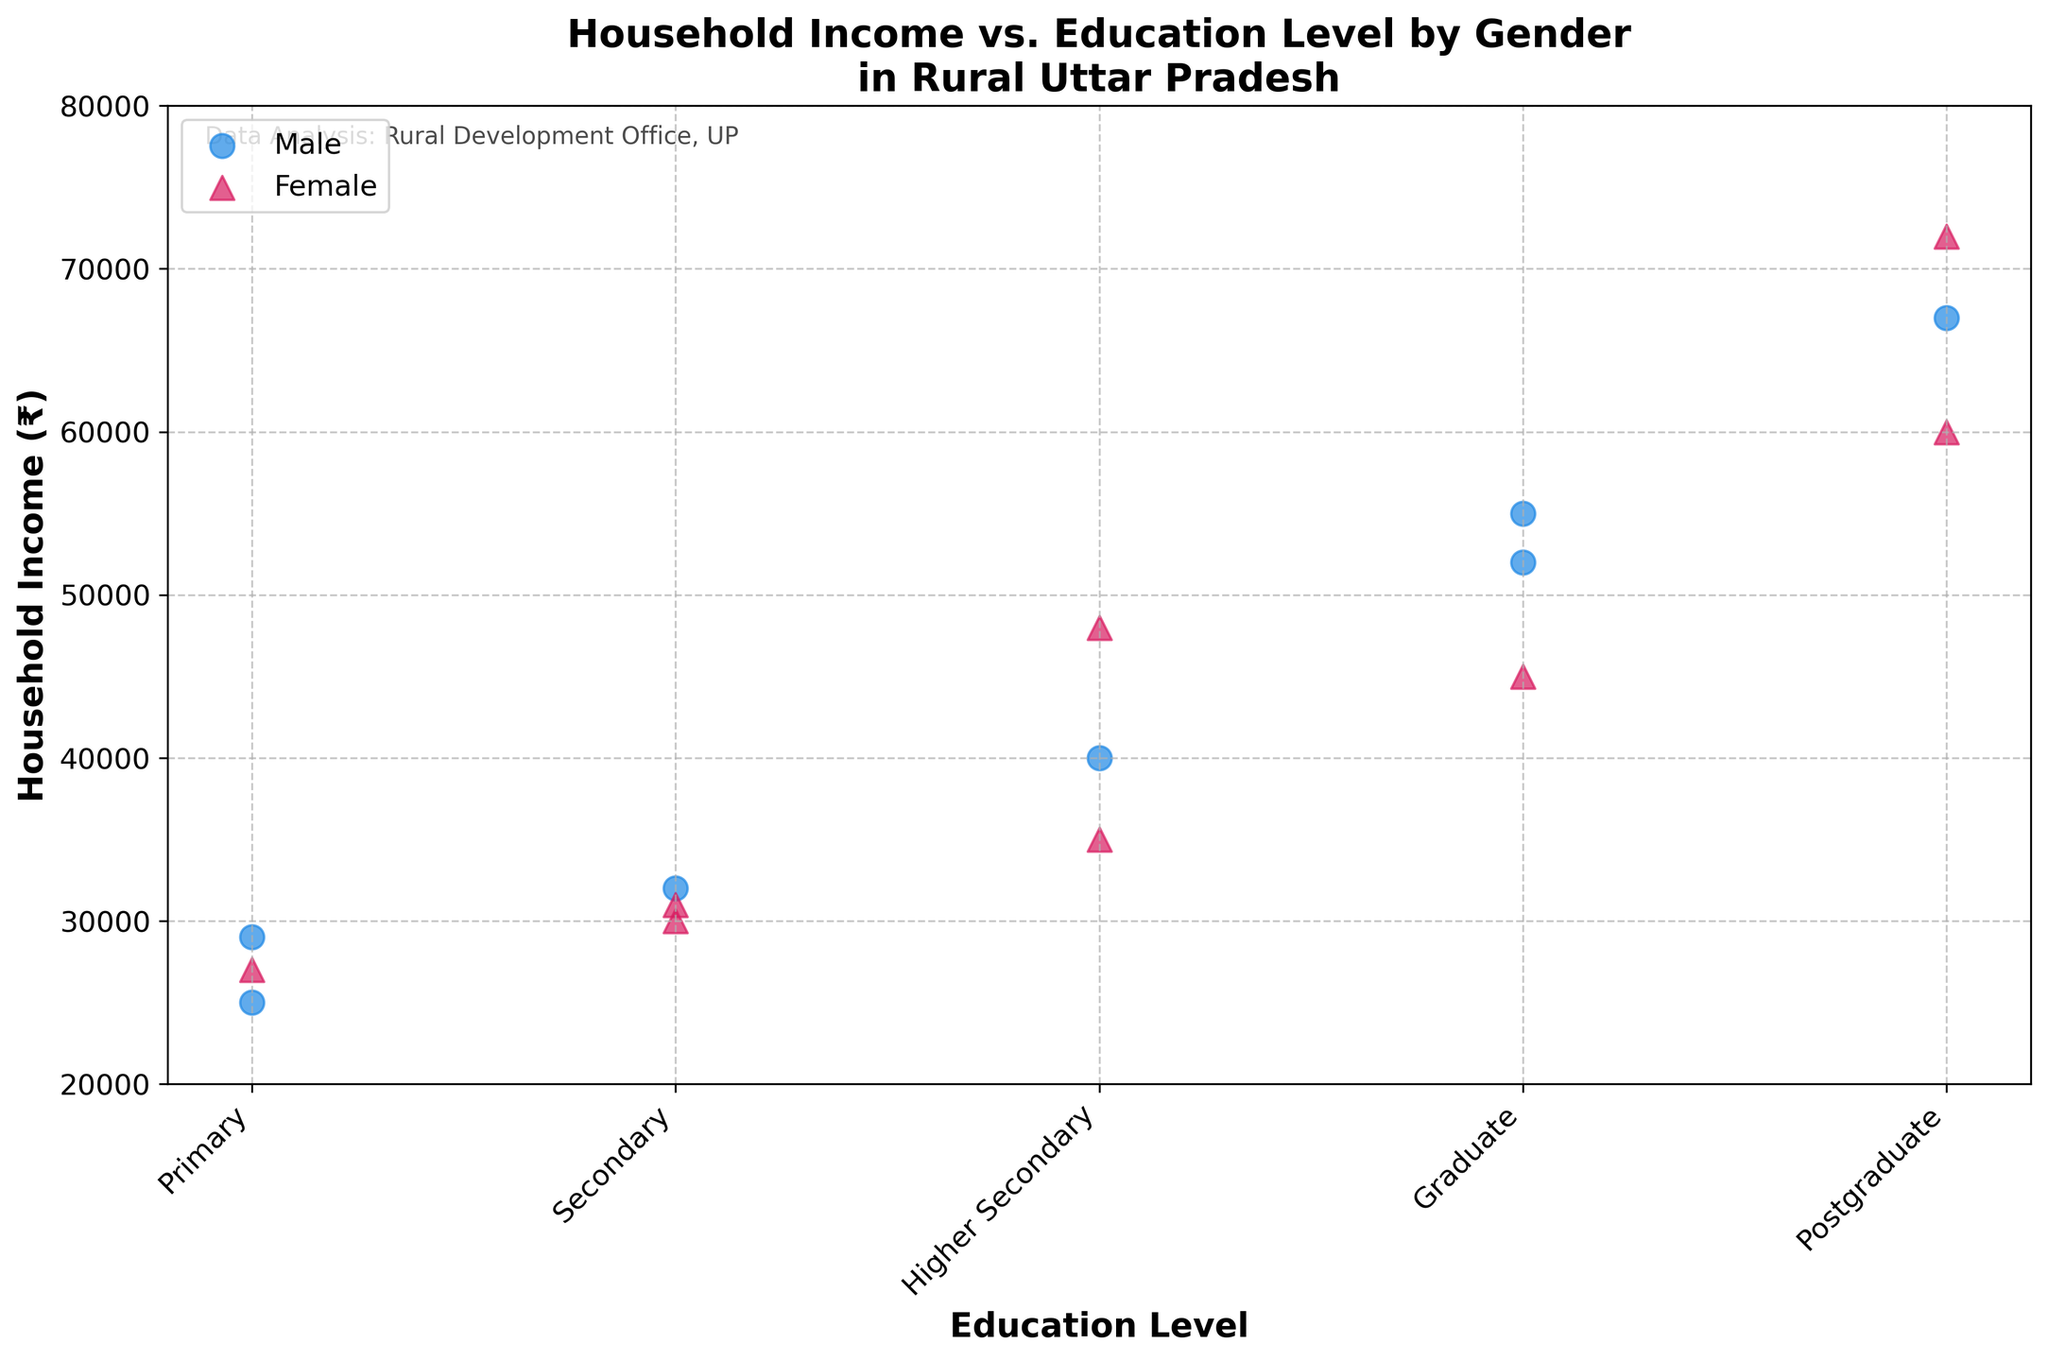What is the title of the plot? The title of the plot is usually located at the top and explains what the plot is about. Here, it provides information on the relationship between education level, household income, and gender in rural Uttar Pradesh.
Answer: Household Income vs. Education Level by Gender in Rural Uttar Pradesh What are the education levels included in the plot? The education levels are listed on the x-axis of the plot. They categorize the data points into different groups based on education.
Answer: Primary, Secondary, Higher Secondary, Graduate, Postgraduate What is the range of household income shown in the plot? The y-axis of the plot represents the household income. It is important to identify the minimum and maximum values displayed on this axis to understand the range covered.
Answer: ₹20,000 to ₹80,000 How many data points are represented by triangles in the 'Graduate' category? Triangles represent the female data points. By counting the number of triangles in the 'Graduate' category, we can determine how many female data points are present.
Answer: 1 Which gender has a higher household income in the 'Postgraduate' category? To compare, observe the income values of both genders within the 'Postgraduate' category. Check which data points (circle for male and triangle for female) are higher on the y-axis.
Answer: Female What is the average household income for males in the 'Graduate' category? For this, find all the male data points in the 'Graduate' category and calculate their average. \( (55000 + 52000) / 2 = 53500 \)
Answer: ₹53,500 In which education level is the difference in household income between genders the largest? Identify the differences in household income between males and females for each education level by calculating them and comparing them to find the largest one.
Answer: Postgraduate Are there more male or female data points in the 'Primary' category? Count the number of male (circle) and female (triangle) data points in the 'Primary' category to determine which gender has more points.
Answer: Equal Which education level has the smallest range of household incomes for females? To determine this, calculate the range (max - min) of household incomes for females in each education level and identify the smallest.
Answer: Secondary 